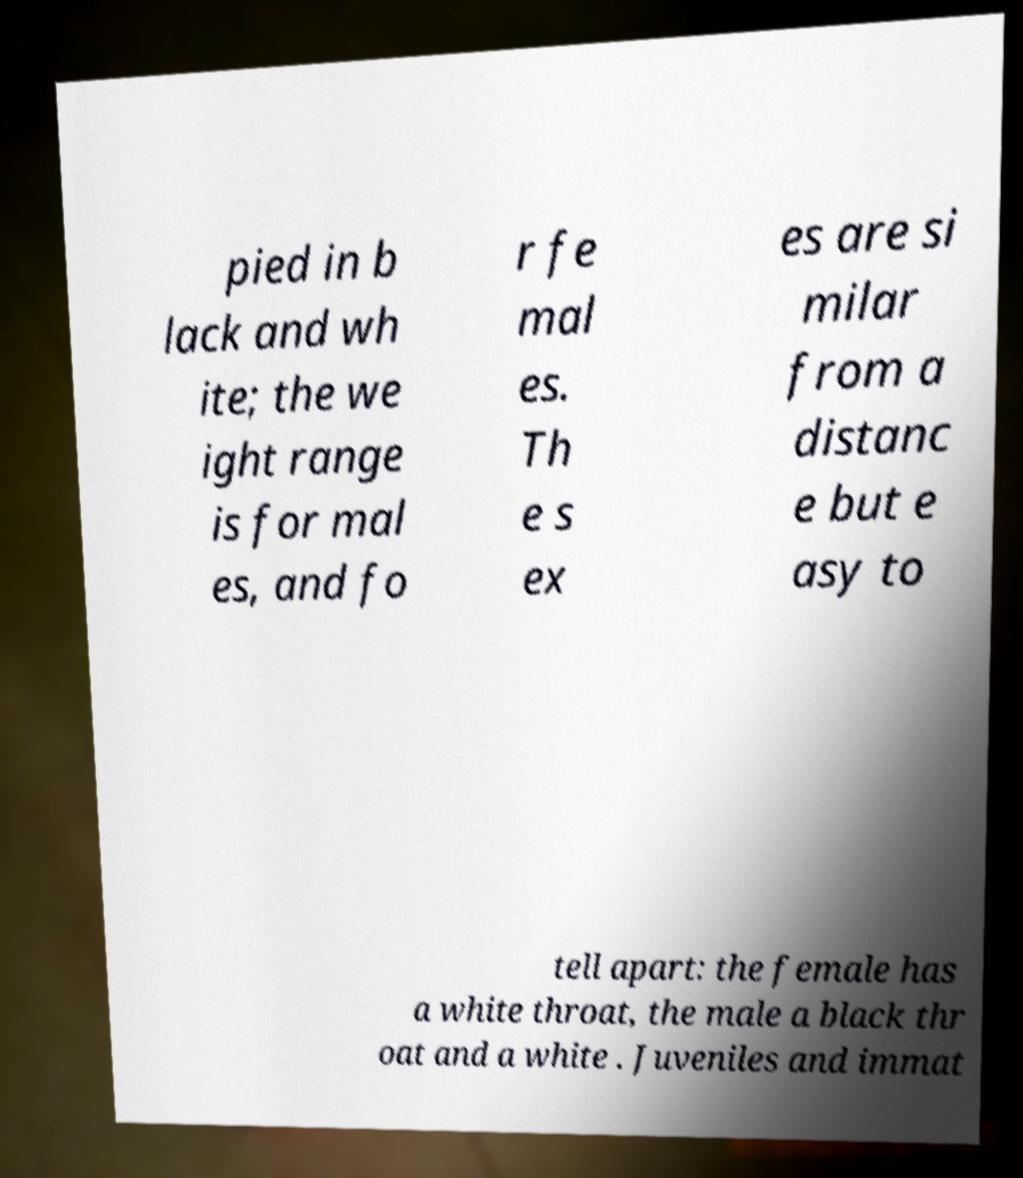Can you accurately transcribe the text from the provided image for me? pied in b lack and wh ite; the we ight range is for mal es, and fo r fe mal es. Th e s ex es are si milar from a distanc e but e asy to tell apart: the female has a white throat, the male a black thr oat and a white . Juveniles and immat 